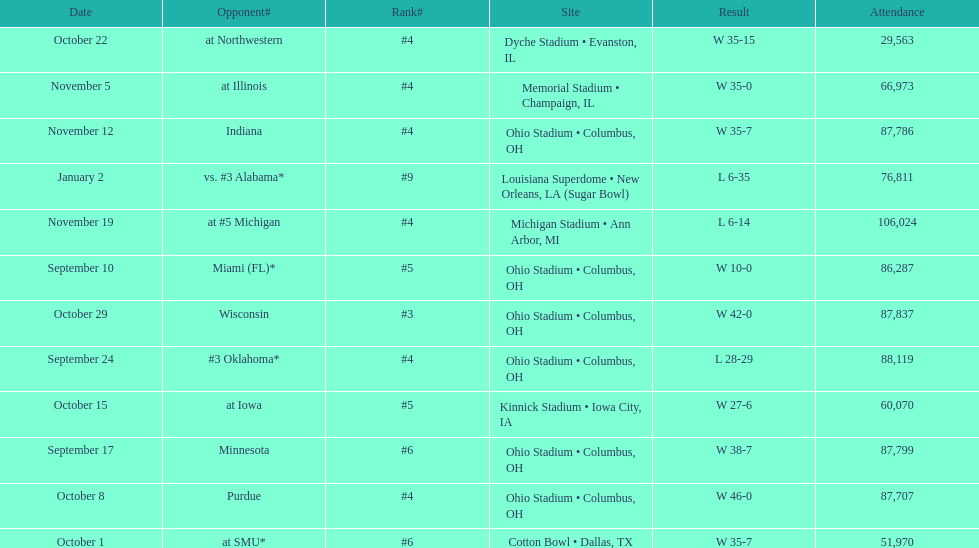What was the last game to be attended by fewer than 30,000 people? October 22. 